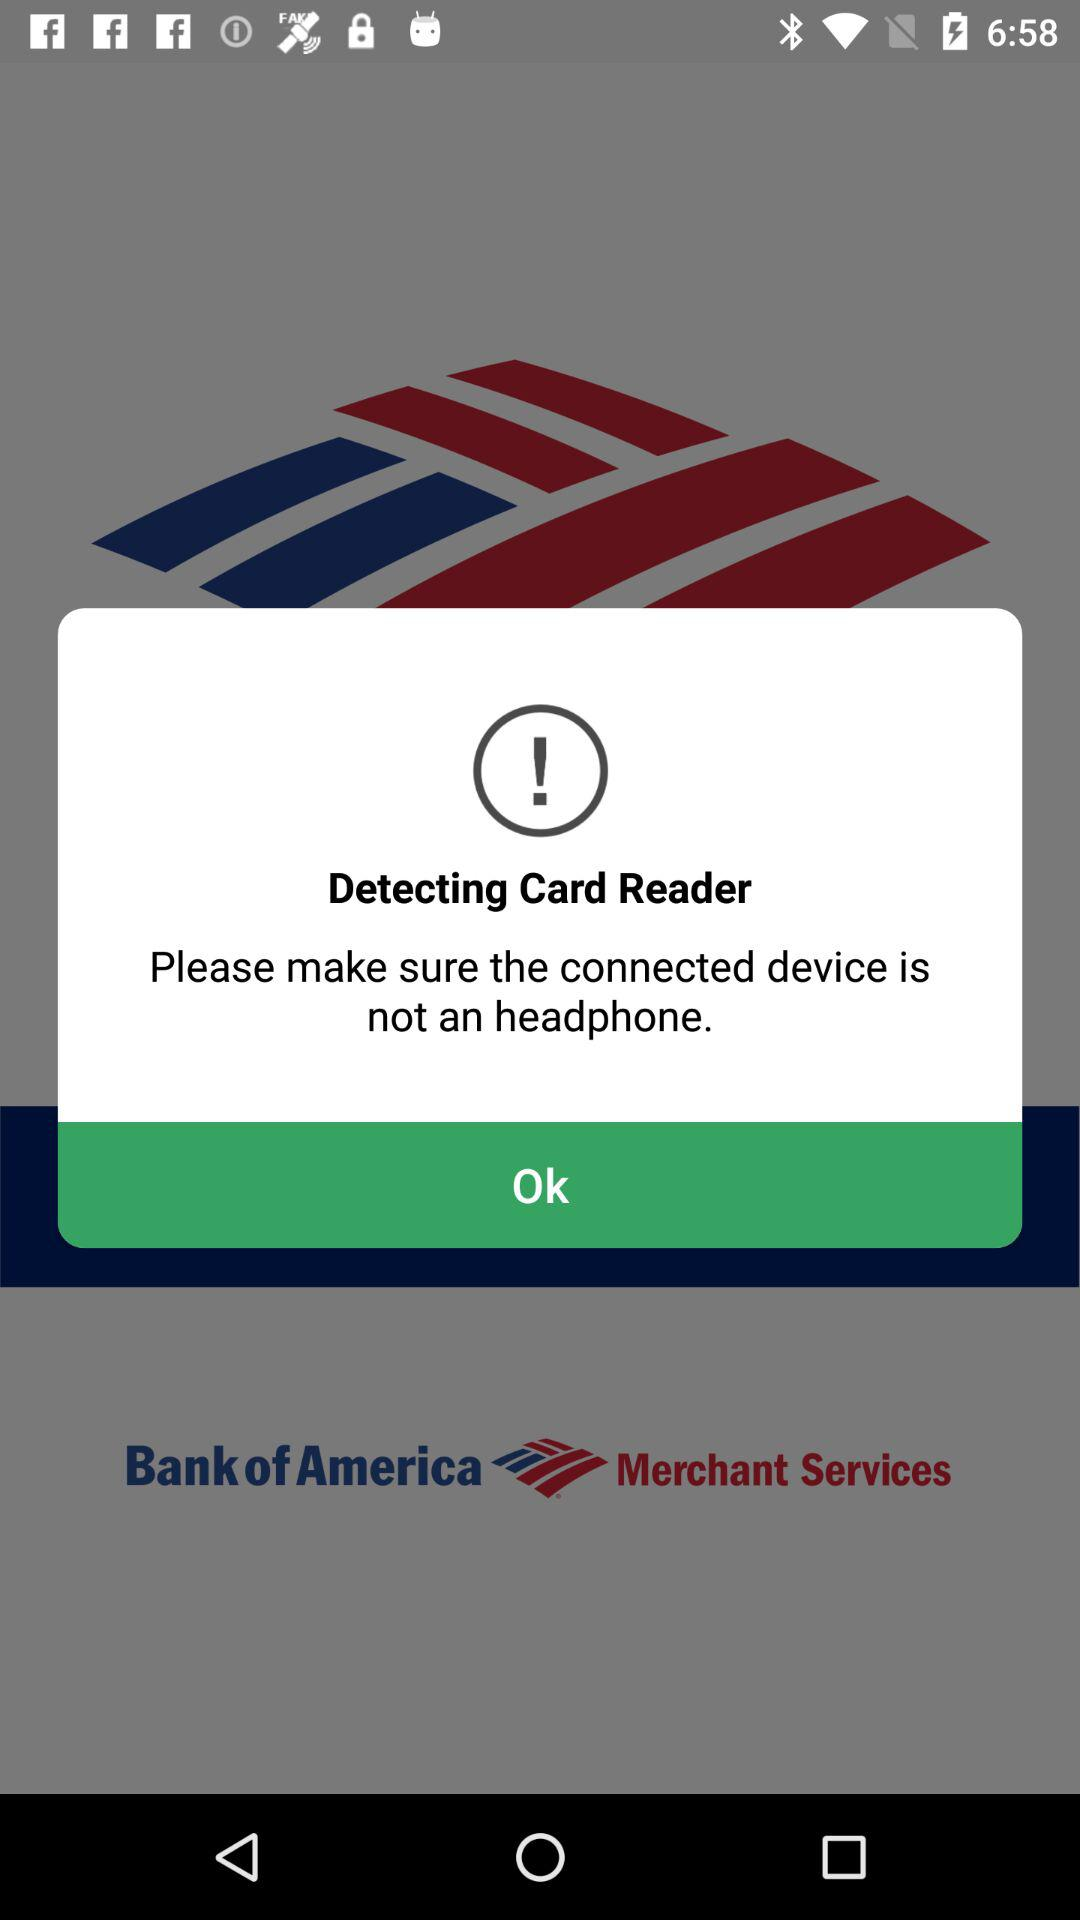What is the app name? The app name is "Bank of America". 